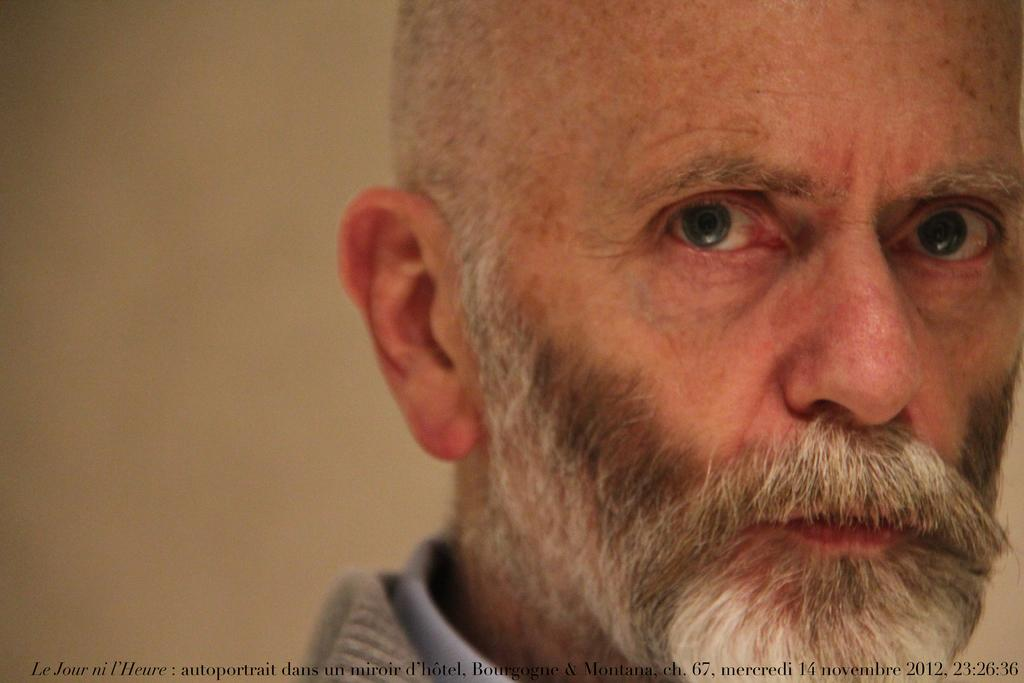What is the main subject of the image? The main subject of the image is the face of a man. Is there any text associated with the image? Yes, there is some text at the bottom of the picture. How many horns does the man have on his head in the image? There are no horns visible on the man's head in the image. What type of sack is being used to carry the man in the image? There is no sack or any indication of the man being carried in the image. 